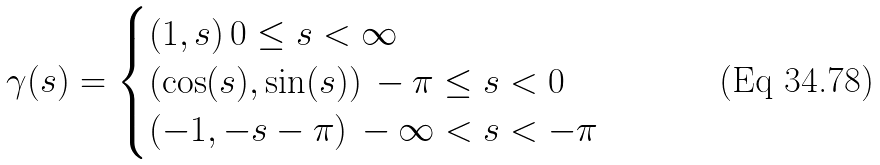Convert formula to latex. <formula><loc_0><loc_0><loc_500><loc_500>\gamma ( s ) = \begin{cases} ( 1 , s ) \, 0 \leq s < \infty \\ ( \cos ( s ) , \sin ( s ) ) \, - \pi \leq s < 0 \\ ( - 1 , - s - \pi ) \, - \infty < s < - \pi \end{cases}</formula> 